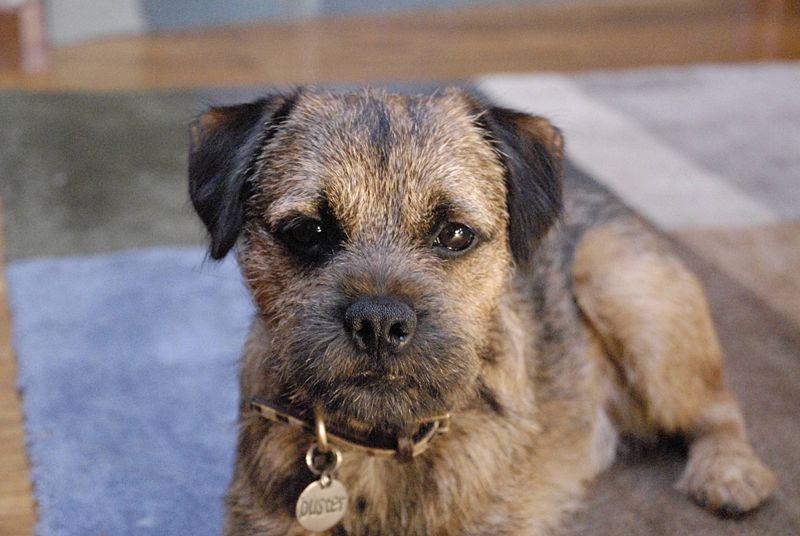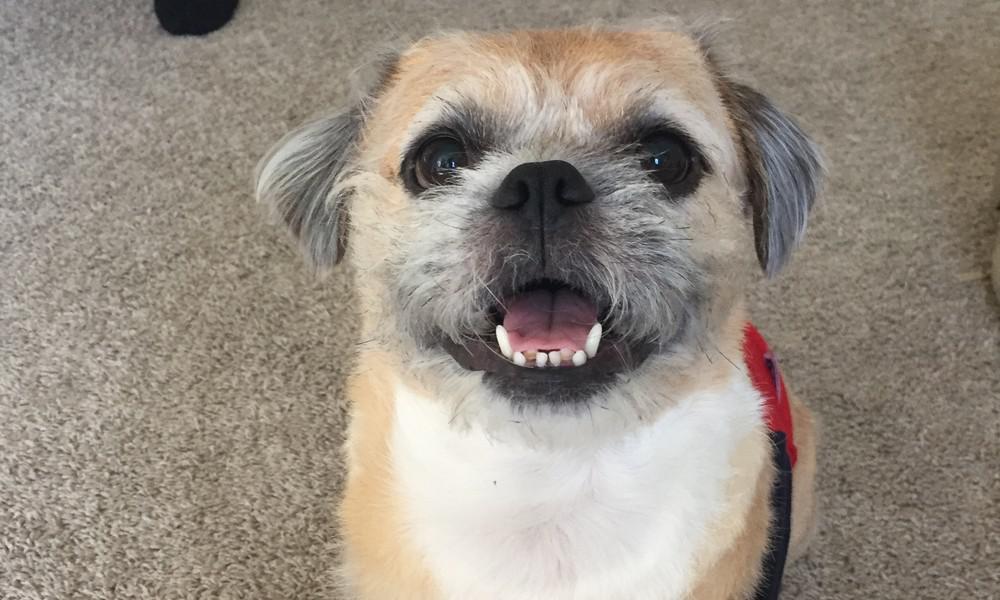The first image is the image on the left, the second image is the image on the right. Examine the images to the left and right. Is the description "One of the dogs has its tongue visible without its teeth showing." accurate? Answer yes or no. No. The first image is the image on the left, the second image is the image on the right. Evaluate the accuracy of this statement regarding the images: "All images show one dog that is standing.". Is it true? Answer yes or no. No. 